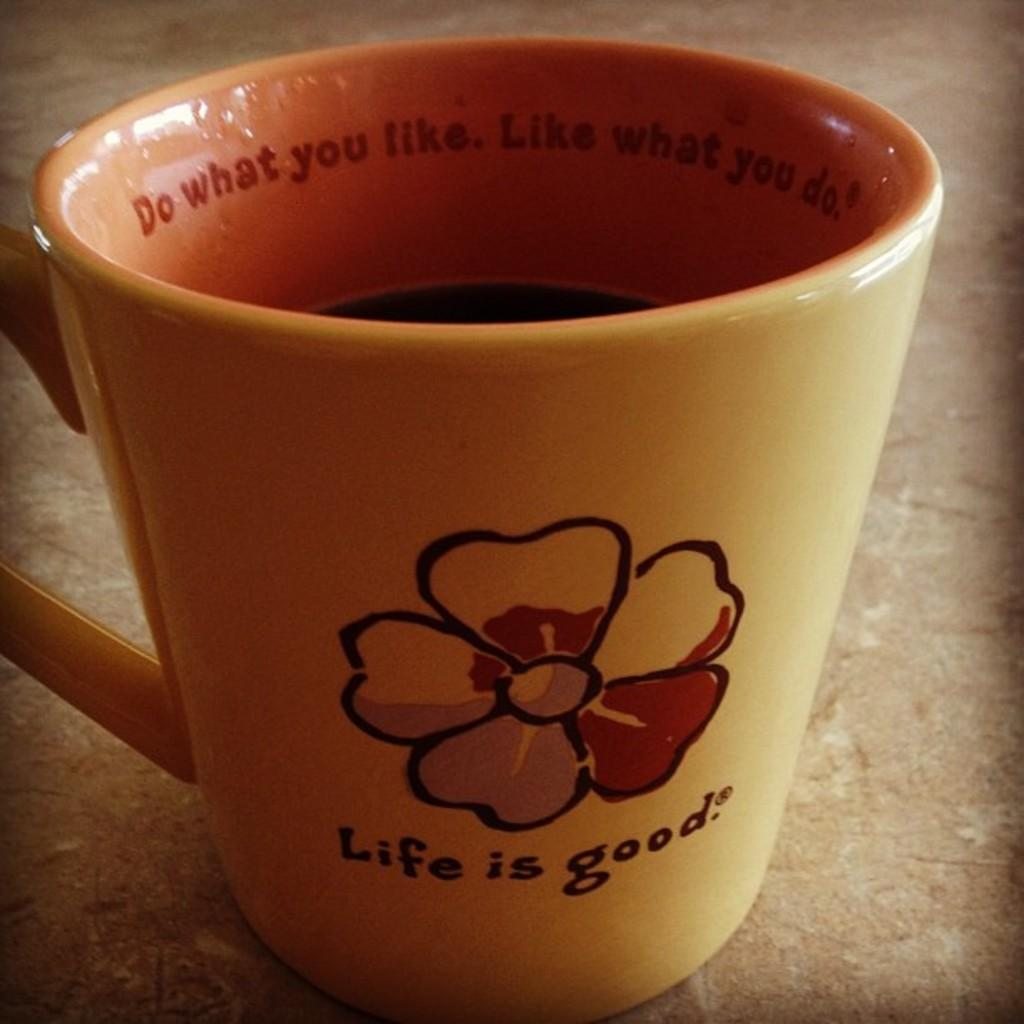What is in the cup that is visible in the image? There is a cup with liquid in the image. Where is the cup located in the image? The cup is placed on a surface in the image. What can be seen on the cup besides the liquid? There is text on the cup. Is there a squirrel sitting on the floor next to the cup in the image? There is no squirrel present in the image. 